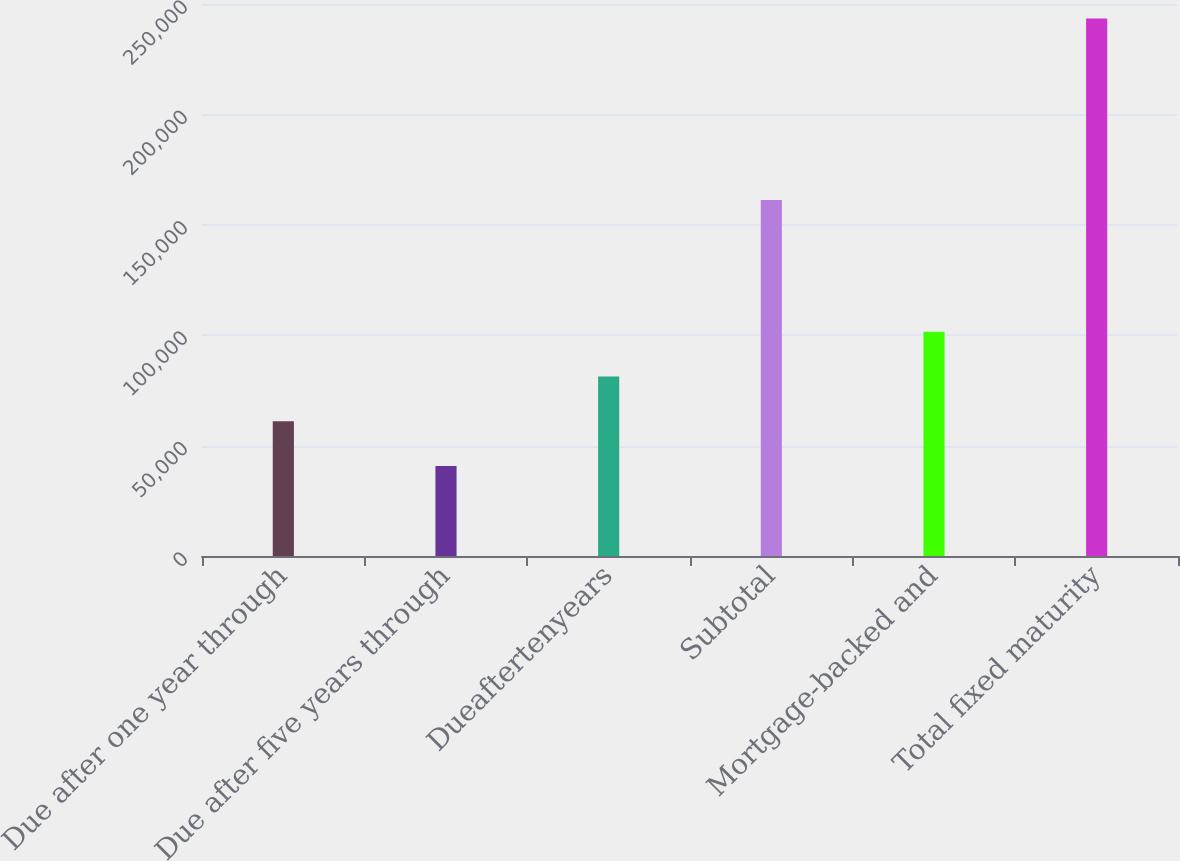Convert chart. <chart><loc_0><loc_0><loc_500><loc_500><bar_chart><fcel>Due after one year through<fcel>Due after five years through<fcel>Dueaftertenyears<fcel>Subtotal<fcel>Mortgage-backed and<fcel>Total fixed maturity<nl><fcel>61078.1<fcel>40817<fcel>81339.2<fcel>161268<fcel>101600<fcel>243428<nl></chart> 